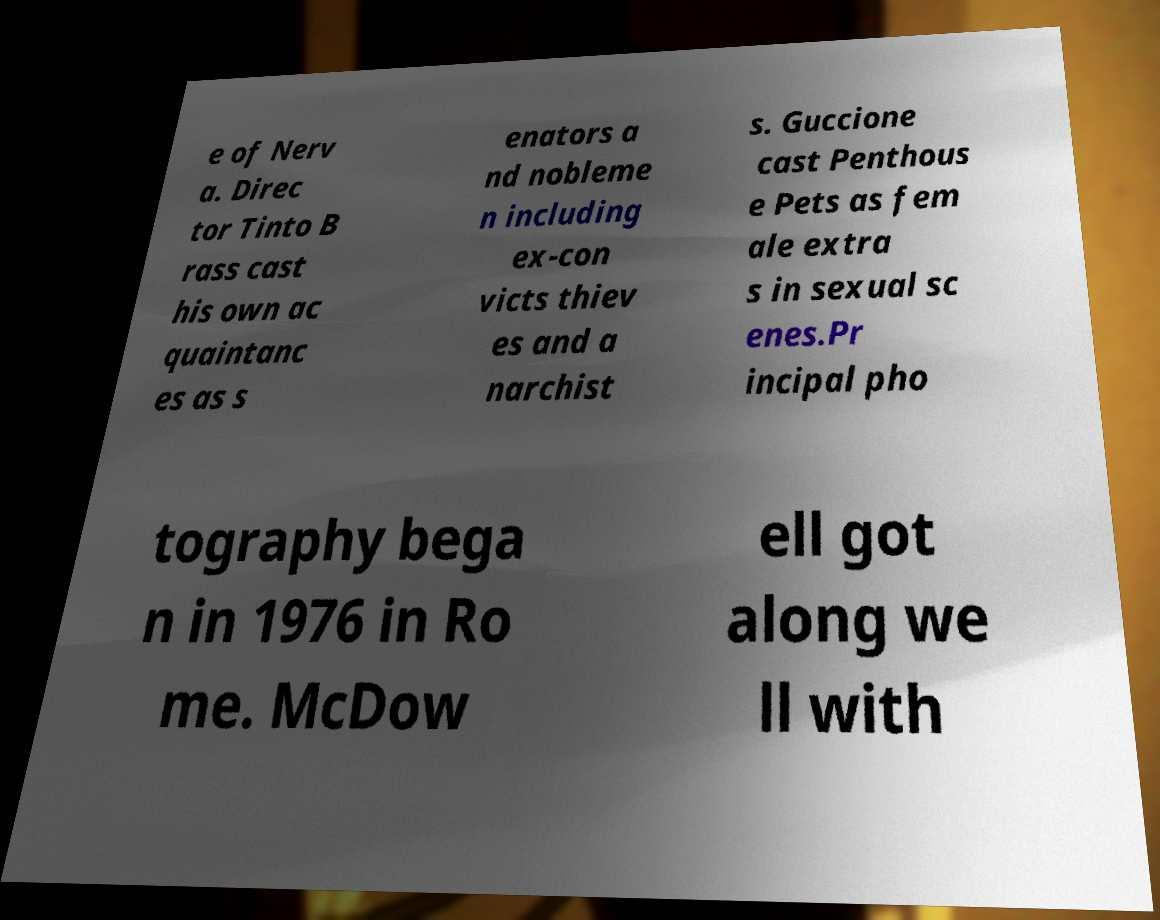Please identify and transcribe the text found in this image. e of Nerv a. Direc tor Tinto B rass cast his own ac quaintanc es as s enators a nd nobleme n including ex-con victs thiev es and a narchist s. Guccione cast Penthous e Pets as fem ale extra s in sexual sc enes.Pr incipal pho tography bega n in 1976 in Ro me. McDow ell got along we ll with 